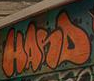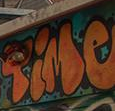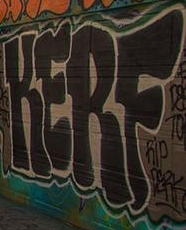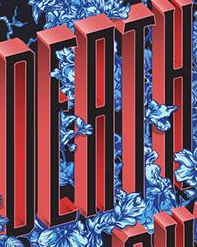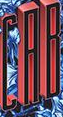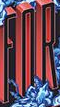What text appears in these images from left to right, separated by a semicolon? HANS; Time; KERF; DEATH; CAB; FOR 